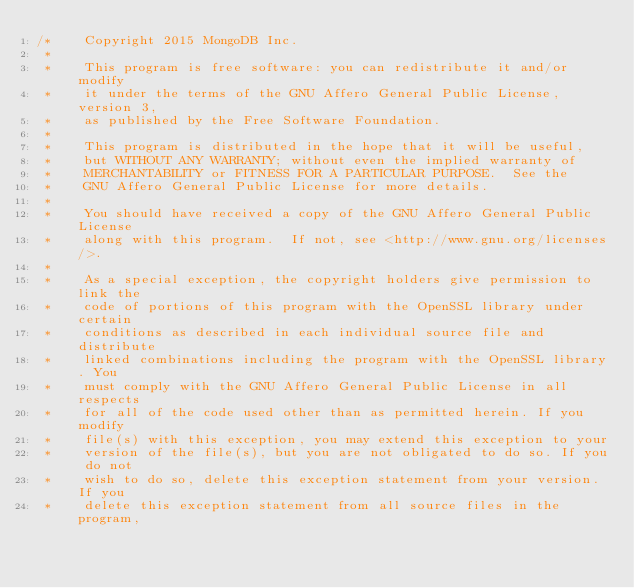Convert code to text. <code><loc_0><loc_0><loc_500><loc_500><_C++_>/*    Copyright 2015 MongoDB Inc.
 *
 *    This program is free software: you can redistribute it and/or  modify
 *    it under the terms of the GNU Affero General Public License, version 3,
 *    as published by the Free Software Foundation.
 *
 *    This program is distributed in the hope that it will be useful,
 *    but WITHOUT ANY WARRANTY; without even the implied warranty of
 *    MERCHANTABILITY or FITNESS FOR A PARTICULAR PURPOSE.  See the
 *    GNU Affero General Public License for more details.
 *
 *    You should have received a copy of the GNU Affero General Public License
 *    along with this program.  If not, see <http://www.gnu.org/licenses/>.
 *
 *    As a special exception, the copyright holders give permission to link the
 *    code of portions of this program with the OpenSSL library under certain
 *    conditions as described in each individual source file and distribute
 *    linked combinations including the program with the OpenSSL library. You
 *    must comply with the GNU Affero General Public License in all respects
 *    for all of the code used other than as permitted herein. If you modify
 *    file(s) with this exception, you may extend this exception to your
 *    version of the file(s), but you are not obligated to do so. If you do not
 *    wish to do so, delete this exception statement from your version. If you
 *    delete this exception statement from all source files in the program,</code> 